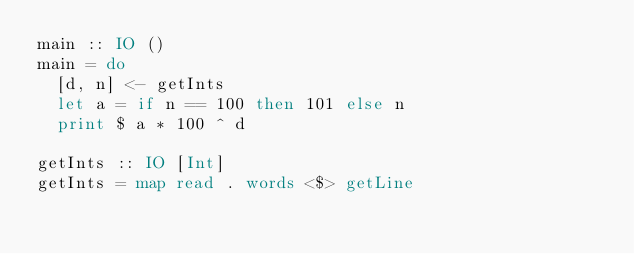Convert code to text. <code><loc_0><loc_0><loc_500><loc_500><_Haskell_>main :: IO ()
main = do
  [d, n] <- getInts
  let a = if n == 100 then 101 else n
  print $ a * 100 ^ d

getInts :: IO [Int]
getInts = map read . words <$> getLine
</code> 